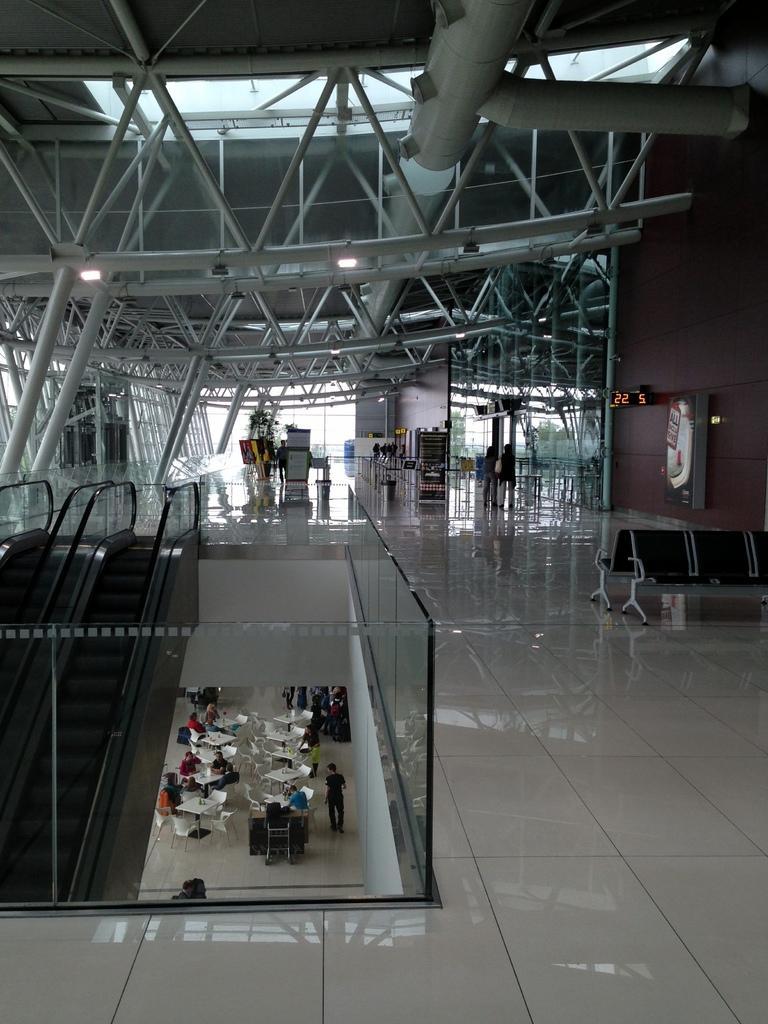In one or two sentences, can you explain what this image depicts? In this image I can see the inner part of the building. To the left there is an escalator. I can also see the group of people sitting on the chairs and few people are standing. In the top I can see the lights and the roof. 